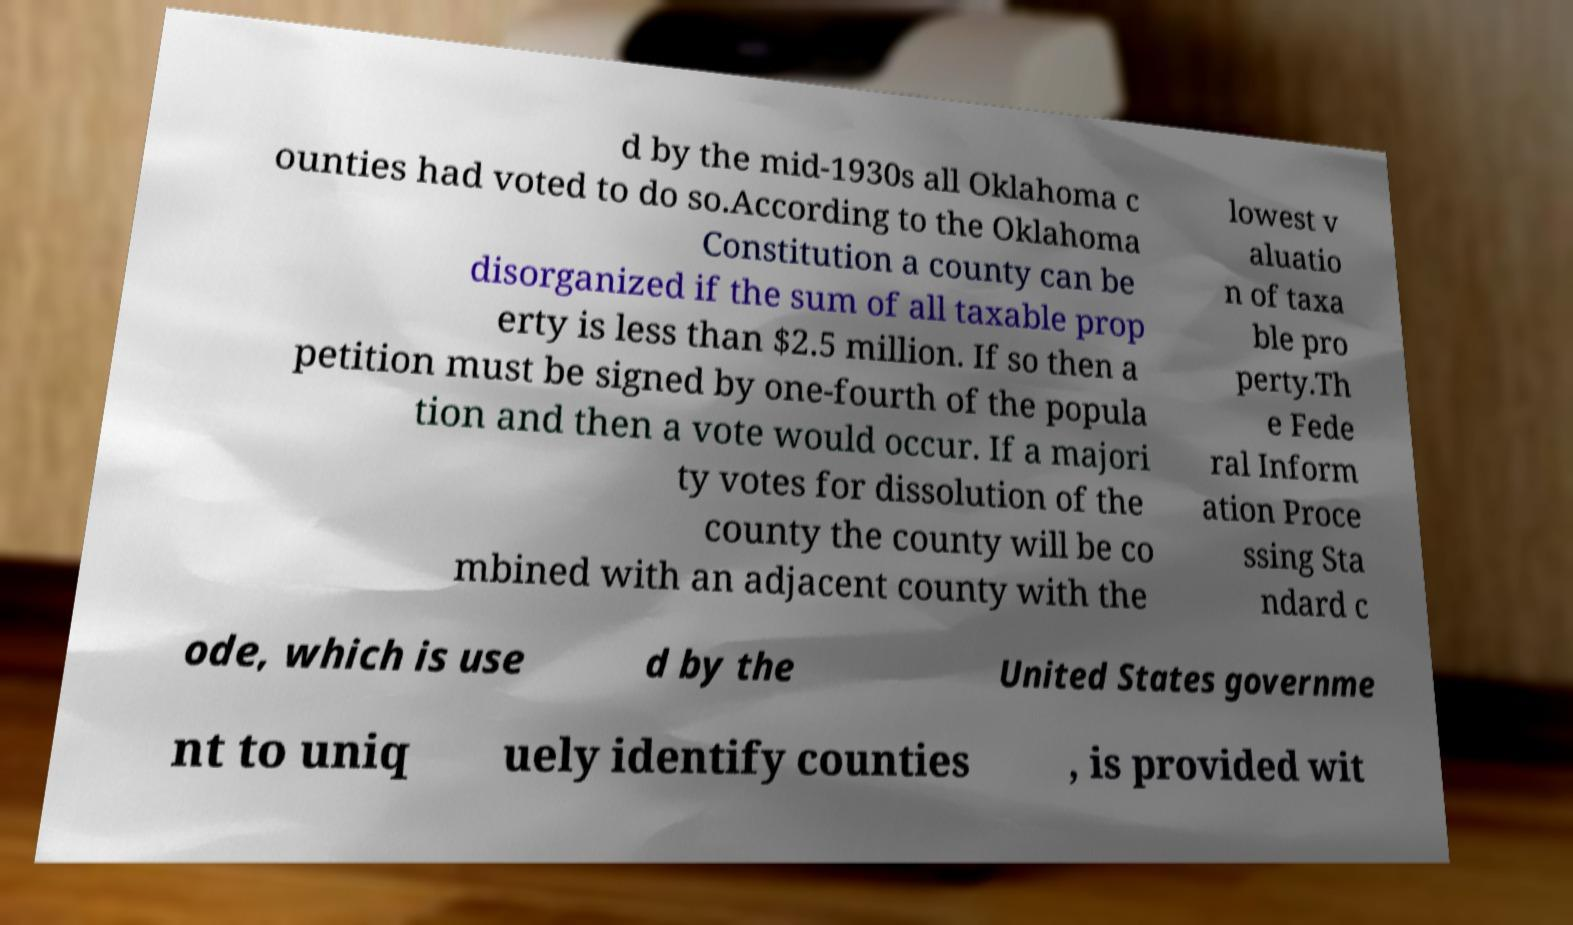Could you assist in decoding the text presented in this image and type it out clearly? d by the mid-1930s all Oklahoma c ounties had voted to do so.According to the Oklahoma Constitution a county can be disorganized if the sum of all taxable prop erty is less than $2.5 million. If so then a petition must be signed by one-fourth of the popula tion and then a vote would occur. If a majori ty votes for dissolution of the county the county will be co mbined with an adjacent county with the lowest v aluatio n of taxa ble pro perty.Th e Fede ral Inform ation Proce ssing Sta ndard c ode, which is use d by the United States governme nt to uniq uely identify counties , is provided wit 